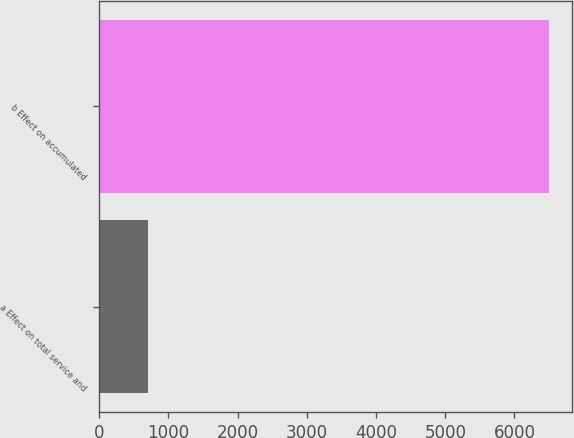Convert chart. <chart><loc_0><loc_0><loc_500><loc_500><bar_chart><fcel>a Effect on total service and<fcel>b Effect on accumulated<nl><fcel>706<fcel>6504<nl></chart> 